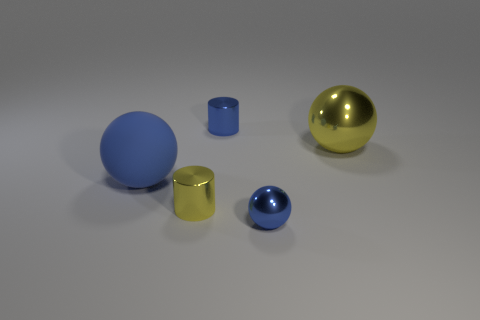Add 3 blue matte spheres. How many objects exist? 8 Subtract all balls. How many objects are left? 2 Subtract all yellow metallic cubes. Subtract all yellow spheres. How many objects are left? 4 Add 3 big yellow shiny spheres. How many big yellow shiny spheres are left? 4 Add 2 large blue blocks. How many large blue blocks exist? 2 Subtract 1 blue spheres. How many objects are left? 4 